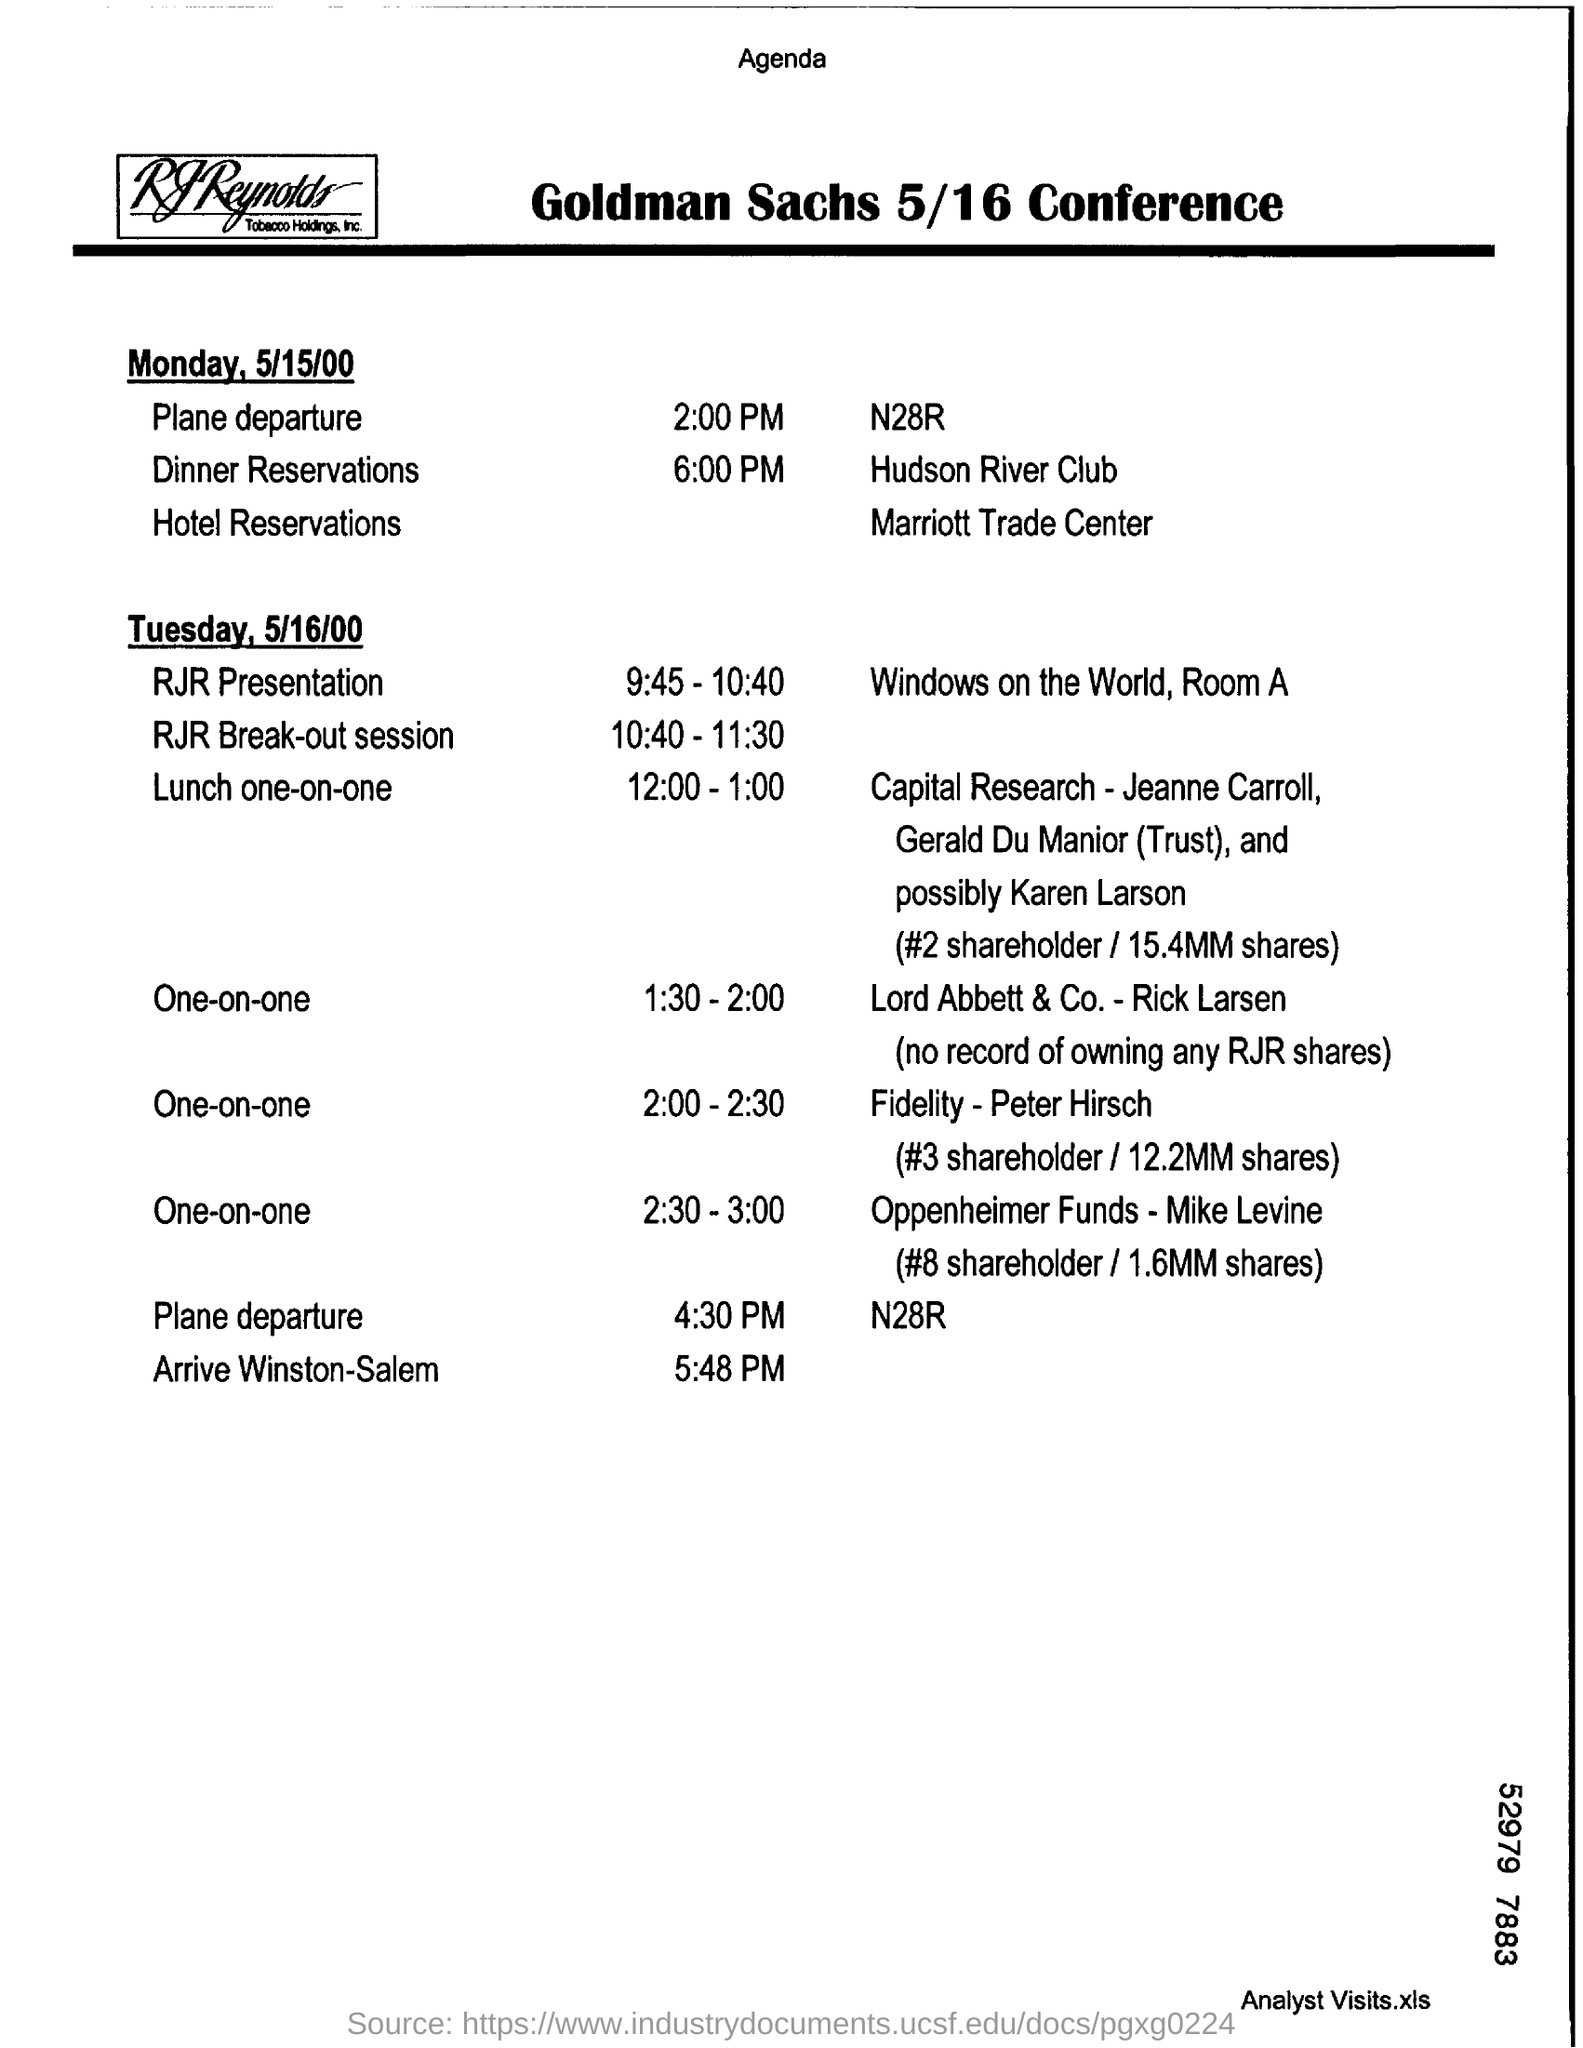Identify some key points in this picture. On which date does the RJR presentation take place? May 16, 2000. During the time interval of 10:40 to 11:30, a session known as the RJR Break-out Session was conducted. On Monday, May 15, 2000, the plane departs at 2:00 PM. The plane is scheduled to arrive in Winston-Salem at 5:48 PM. The Goldman Sachs 5/16 Conference Agenda is mentioned in the text. 